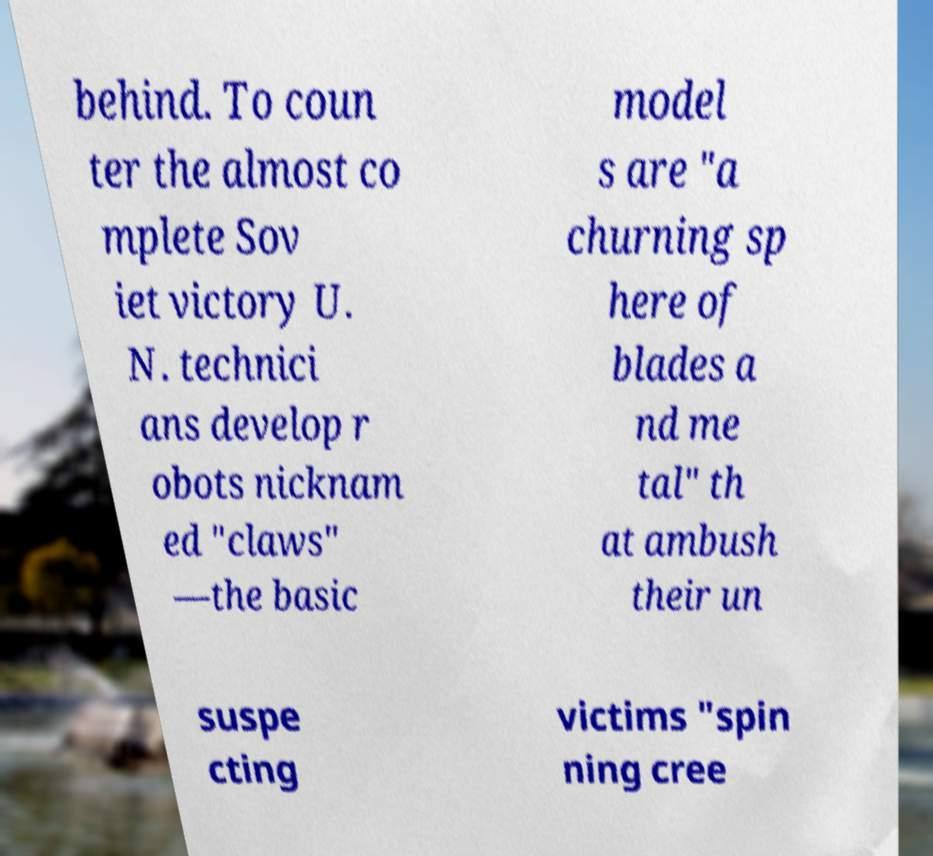Can you read and provide the text displayed in the image?This photo seems to have some interesting text. Can you extract and type it out for me? behind. To coun ter the almost co mplete Sov iet victory U. N. technici ans develop r obots nicknam ed "claws" —the basic model s are "a churning sp here of blades a nd me tal" th at ambush their un suspe cting victims "spin ning cree 